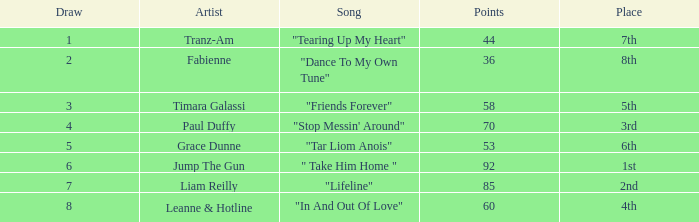What's the total number of points for grace dunne with a draw over 5? 0.0. 